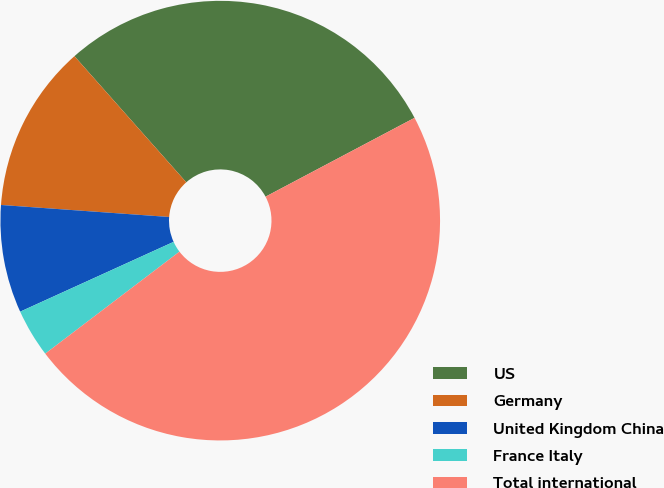Convert chart to OTSL. <chart><loc_0><loc_0><loc_500><loc_500><pie_chart><fcel>US<fcel>Germany<fcel>United Kingdom China<fcel>France Italy<fcel>Total international<nl><fcel>28.8%<fcel>12.32%<fcel>7.93%<fcel>3.55%<fcel>47.4%<nl></chart> 